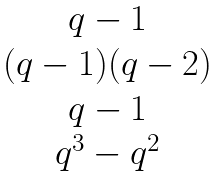<formula> <loc_0><loc_0><loc_500><loc_500>\begin{matrix} q - 1 \\ ( q - 1 ) ( q - 2 ) \\ q - 1 \\ q ^ { 3 } - q ^ { 2 } \end{matrix}</formula> 